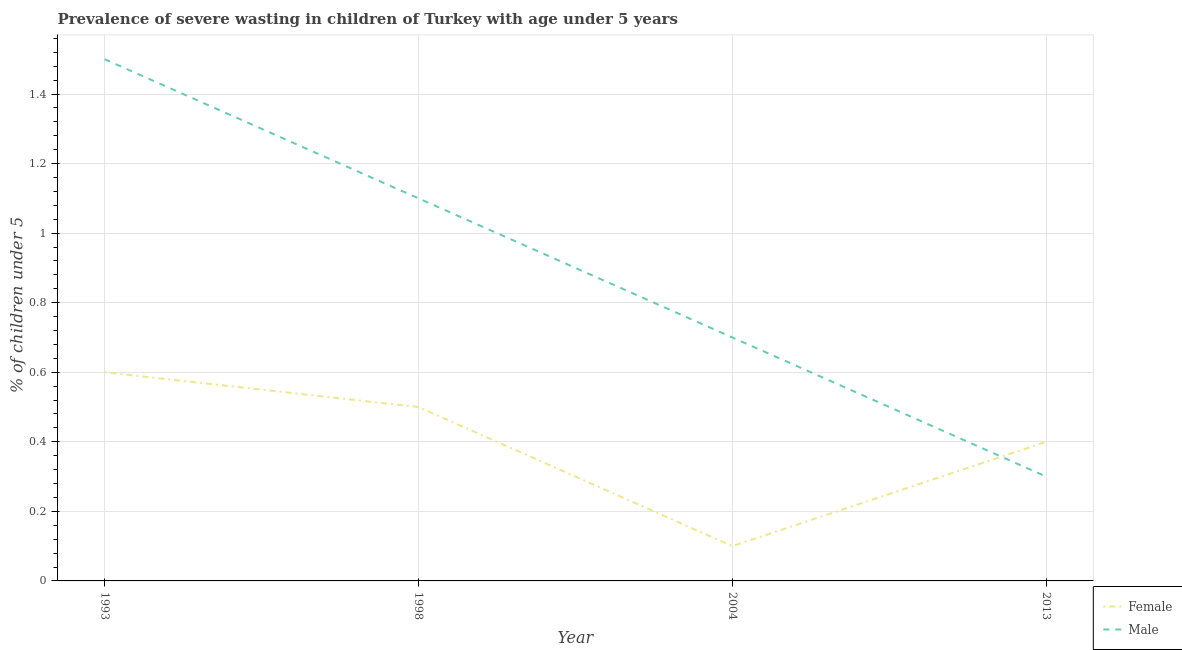Is the number of lines equal to the number of legend labels?
Offer a terse response. Yes. What is the percentage of undernourished male children in 2004?
Offer a very short reply. 0.7. Across all years, what is the minimum percentage of undernourished male children?
Your answer should be very brief. 0.3. In which year was the percentage of undernourished female children maximum?
Make the answer very short. 1993. What is the total percentage of undernourished female children in the graph?
Your answer should be very brief. 1.6. What is the difference between the percentage of undernourished female children in 1993 and that in 2013?
Offer a very short reply. 0.2. What is the difference between the percentage of undernourished male children in 2013 and the percentage of undernourished female children in 1998?
Provide a succinct answer. -0.2. What is the average percentage of undernourished female children per year?
Your answer should be compact. 0.4. In the year 1993, what is the difference between the percentage of undernourished male children and percentage of undernourished female children?
Your answer should be very brief. 0.9. In how many years, is the percentage of undernourished male children greater than 1.2800000000000002 %?
Provide a short and direct response. 1. What is the ratio of the percentage of undernourished female children in 1993 to that in 2013?
Provide a short and direct response. 1.5. Is the percentage of undernourished male children in 1993 less than that in 2013?
Keep it short and to the point. No. Is the difference between the percentage of undernourished female children in 1993 and 1998 greater than the difference between the percentage of undernourished male children in 1993 and 1998?
Offer a terse response. No. What is the difference between the highest and the second highest percentage of undernourished male children?
Ensure brevity in your answer.  0.4. What is the difference between the highest and the lowest percentage of undernourished female children?
Ensure brevity in your answer.  0.5. Does the percentage of undernourished female children monotonically increase over the years?
Ensure brevity in your answer.  No. Is the percentage of undernourished male children strictly less than the percentage of undernourished female children over the years?
Ensure brevity in your answer.  No. Does the graph contain any zero values?
Offer a terse response. No. Where does the legend appear in the graph?
Provide a short and direct response. Bottom right. How many legend labels are there?
Keep it short and to the point. 2. How are the legend labels stacked?
Your response must be concise. Vertical. What is the title of the graph?
Your answer should be very brief. Prevalence of severe wasting in children of Turkey with age under 5 years. What is the label or title of the X-axis?
Make the answer very short. Year. What is the label or title of the Y-axis?
Provide a short and direct response.  % of children under 5. What is the  % of children under 5 in Female in 1993?
Offer a very short reply. 0.6. What is the  % of children under 5 in Male in 1993?
Ensure brevity in your answer.  1.5. What is the  % of children under 5 of Male in 1998?
Ensure brevity in your answer.  1.1. What is the  % of children under 5 of Female in 2004?
Your response must be concise. 0.1. What is the  % of children under 5 in Male in 2004?
Your answer should be compact. 0.7. What is the  % of children under 5 of Female in 2013?
Offer a very short reply. 0.4. What is the  % of children under 5 in Male in 2013?
Offer a very short reply. 0.3. Across all years, what is the maximum  % of children under 5 of Female?
Ensure brevity in your answer.  0.6. Across all years, what is the minimum  % of children under 5 in Female?
Keep it short and to the point. 0.1. Across all years, what is the minimum  % of children under 5 in Male?
Your answer should be very brief. 0.3. What is the difference between the  % of children under 5 of Female in 1993 and that in 1998?
Keep it short and to the point. 0.1. What is the difference between the  % of children under 5 of Male in 1993 and that in 1998?
Make the answer very short. 0.4. What is the difference between the  % of children under 5 in Female in 1993 and that in 2004?
Keep it short and to the point. 0.5. What is the difference between the  % of children under 5 in Male in 1993 and that in 2004?
Offer a terse response. 0.8. What is the difference between the  % of children under 5 in Female in 1993 and that in 2013?
Your response must be concise. 0.2. What is the difference between the  % of children under 5 of Male in 1993 and that in 2013?
Keep it short and to the point. 1.2. What is the difference between the  % of children under 5 in Male in 1998 and that in 2004?
Make the answer very short. 0.4. What is the difference between the  % of children under 5 of Male in 1998 and that in 2013?
Keep it short and to the point. 0.8. What is the difference between the  % of children under 5 of Female in 1993 and the  % of children under 5 of Male in 1998?
Provide a succinct answer. -0.5. What is the difference between the  % of children under 5 in Female in 1993 and the  % of children under 5 in Male in 2013?
Provide a short and direct response. 0.3. What is the difference between the  % of children under 5 in Female in 1998 and the  % of children under 5 in Male in 2004?
Your answer should be compact. -0.2. In the year 2004, what is the difference between the  % of children under 5 in Female and  % of children under 5 in Male?
Provide a succinct answer. -0.6. In the year 2013, what is the difference between the  % of children under 5 of Female and  % of children under 5 of Male?
Provide a succinct answer. 0.1. What is the ratio of the  % of children under 5 in Female in 1993 to that in 1998?
Provide a succinct answer. 1.2. What is the ratio of the  % of children under 5 of Male in 1993 to that in 1998?
Your answer should be compact. 1.36. What is the ratio of the  % of children under 5 in Male in 1993 to that in 2004?
Offer a terse response. 2.14. What is the ratio of the  % of children under 5 of Male in 1998 to that in 2004?
Ensure brevity in your answer.  1.57. What is the ratio of the  % of children under 5 of Male in 1998 to that in 2013?
Make the answer very short. 3.67. What is the ratio of the  % of children under 5 of Female in 2004 to that in 2013?
Offer a terse response. 0.25. What is the ratio of the  % of children under 5 in Male in 2004 to that in 2013?
Your answer should be very brief. 2.33. What is the difference between the highest and the second highest  % of children under 5 in Female?
Your response must be concise. 0.1. What is the difference between the highest and the lowest  % of children under 5 of Male?
Your answer should be very brief. 1.2. 